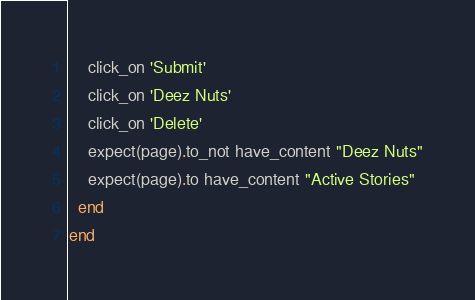<code> <loc_0><loc_0><loc_500><loc_500><_Ruby_>    click_on 'Submit'
    click_on 'Deez Nuts'
    click_on 'Delete'
    expect(page).to_not have_content "Deez Nuts"
    expect(page).to have_content "Active Stories"
  end
end
</code> 